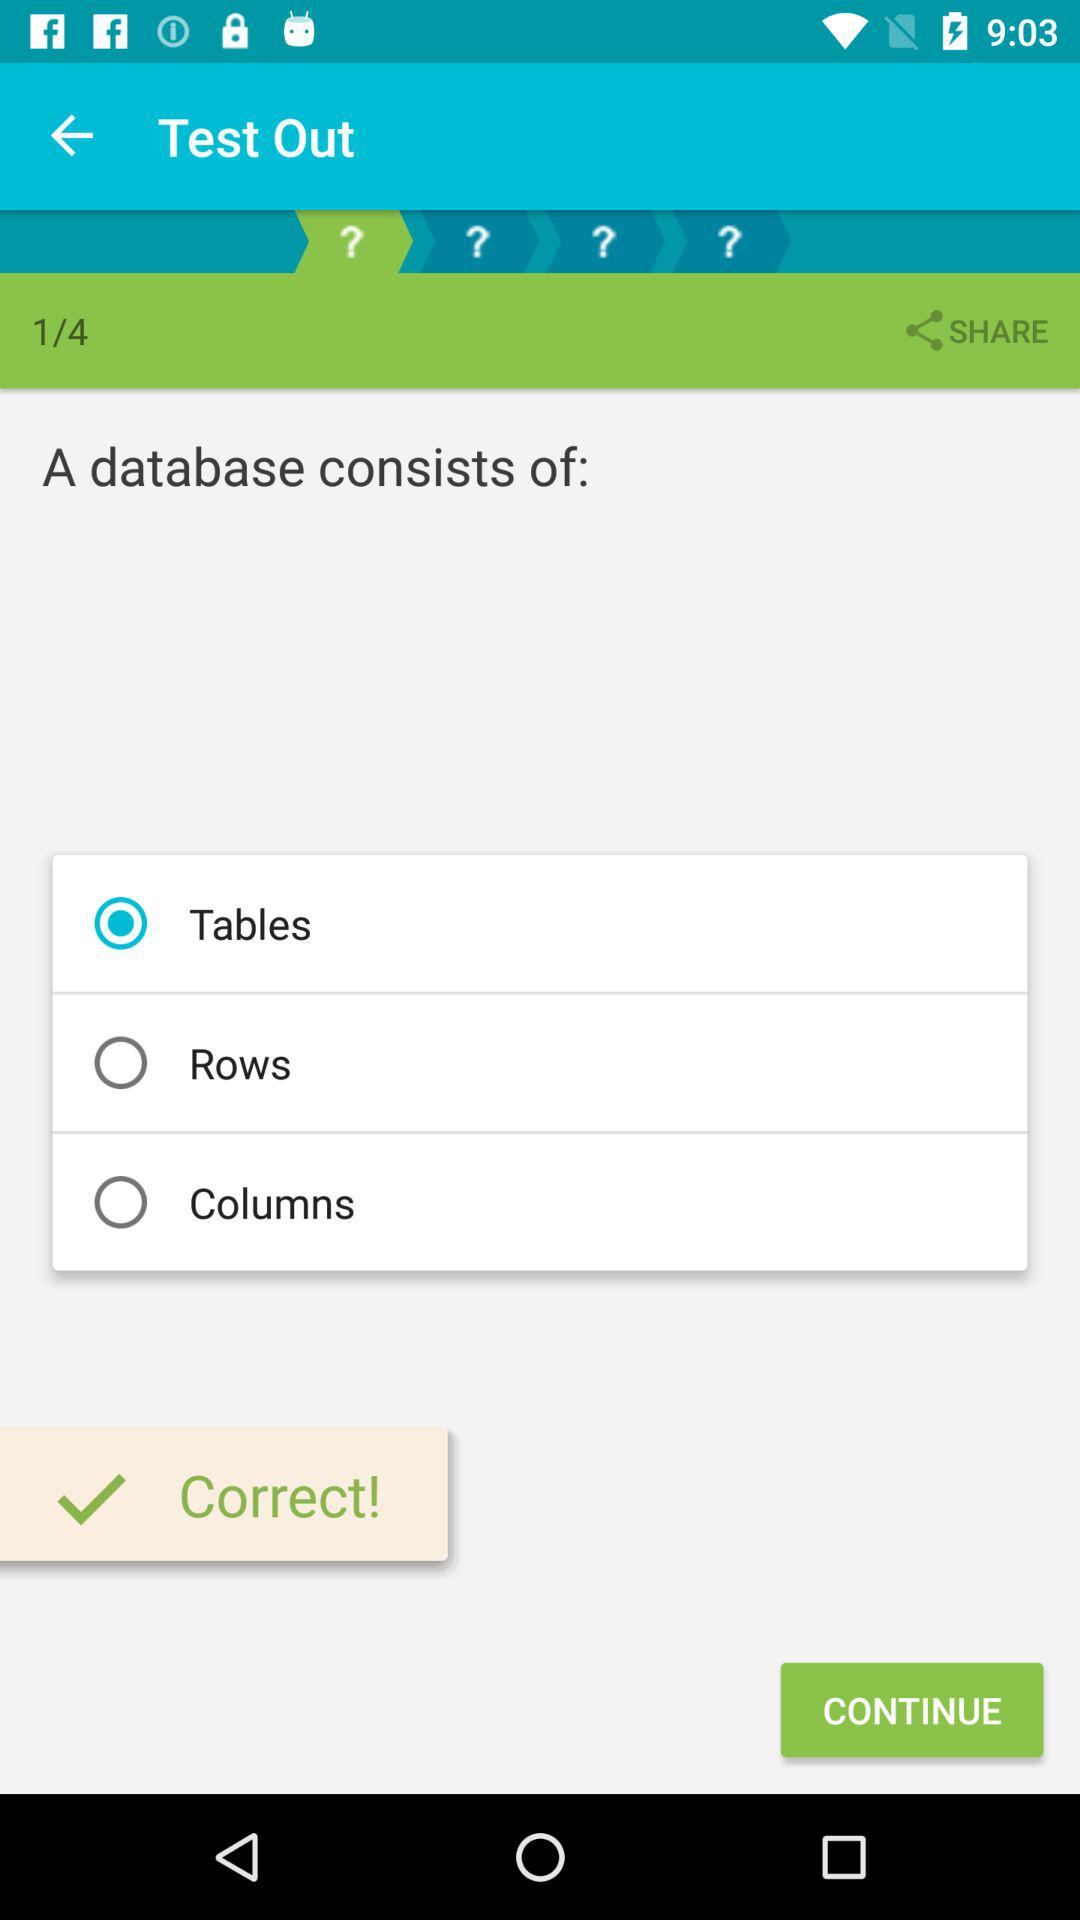Which question number am I on? You are on question number 1. 